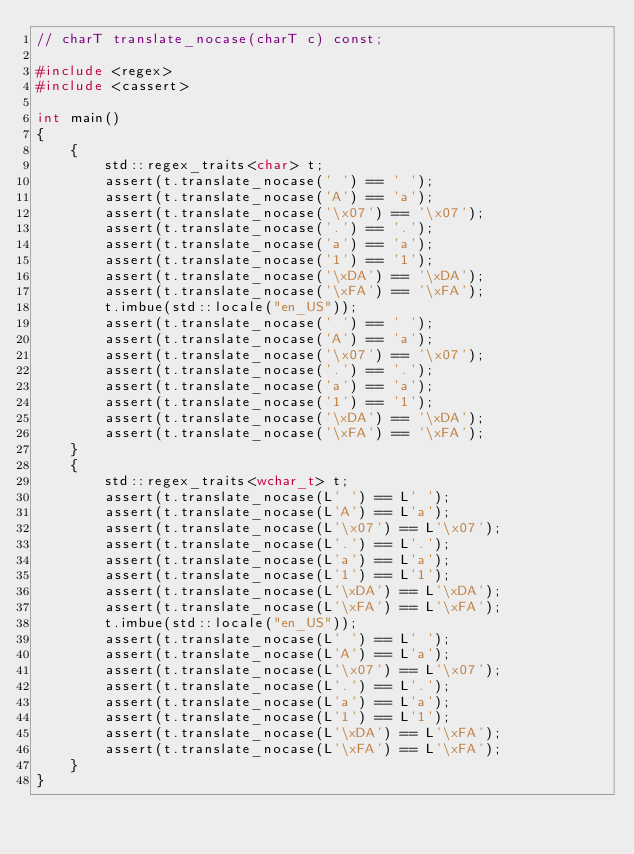Convert code to text. <code><loc_0><loc_0><loc_500><loc_500><_C++_>// charT translate_nocase(charT c) const;

#include <regex>
#include <cassert>

int main()
{
    {
        std::regex_traits<char> t;
        assert(t.translate_nocase(' ') == ' ');
        assert(t.translate_nocase('A') == 'a');
        assert(t.translate_nocase('\x07') == '\x07');
        assert(t.translate_nocase('.') == '.');
        assert(t.translate_nocase('a') == 'a');
        assert(t.translate_nocase('1') == '1');
        assert(t.translate_nocase('\xDA') == '\xDA');
        assert(t.translate_nocase('\xFA') == '\xFA');
        t.imbue(std::locale("en_US"));
        assert(t.translate_nocase(' ') == ' ');
        assert(t.translate_nocase('A') == 'a');
        assert(t.translate_nocase('\x07') == '\x07');
        assert(t.translate_nocase('.') == '.');
        assert(t.translate_nocase('a') == 'a');
        assert(t.translate_nocase('1') == '1');
        assert(t.translate_nocase('\xDA') == '\xDA');
        assert(t.translate_nocase('\xFA') == '\xFA');
    }
    {
        std::regex_traits<wchar_t> t;
        assert(t.translate_nocase(L' ') == L' ');
        assert(t.translate_nocase(L'A') == L'a');
        assert(t.translate_nocase(L'\x07') == L'\x07');
        assert(t.translate_nocase(L'.') == L'.');
        assert(t.translate_nocase(L'a') == L'a');
        assert(t.translate_nocase(L'1') == L'1');
        assert(t.translate_nocase(L'\xDA') == L'\xDA');
        assert(t.translate_nocase(L'\xFA') == L'\xFA');
        t.imbue(std::locale("en_US"));
        assert(t.translate_nocase(L' ') == L' ');
        assert(t.translate_nocase(L'A') == L'a');
        assert(t.translate_nocase(L'\x07') == L'\x07');
        assert(t.translate_nocase(L'.') == L'.');
        assert(t.translate_nocase(L'a') == L'a');
        assert(t.translate_nocase(L'1') == L'1');
        assert(t.translate_nocase(L'\xDA') == L'\xFA');
        assert(t.translate_nocase(L'\xFA') == L'\xFA');
    }
}
</code> 